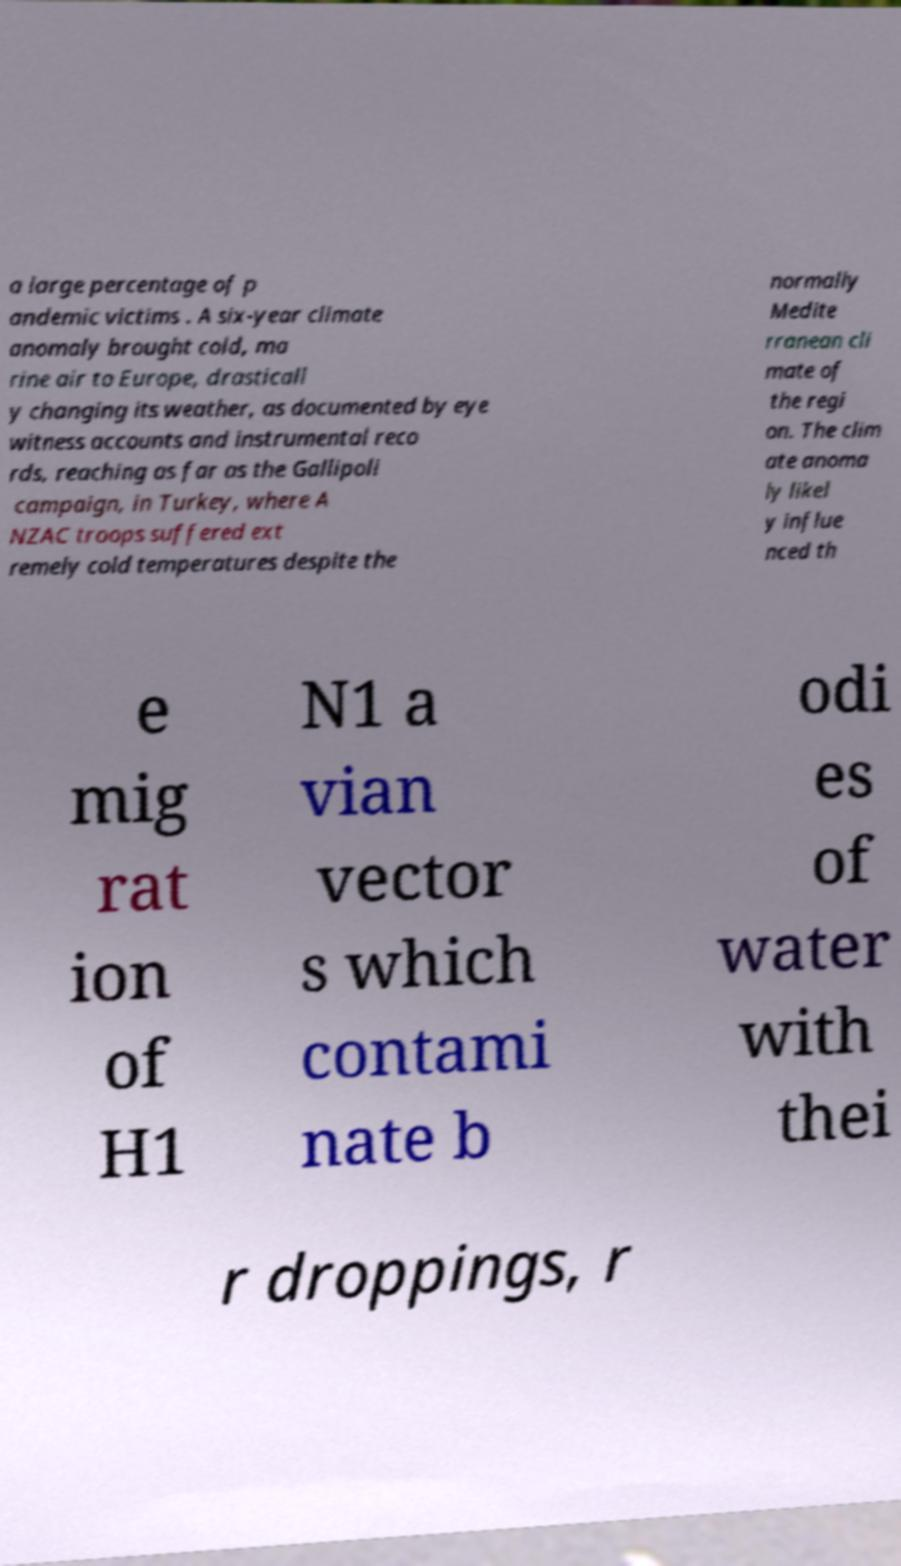There's text embedded in this image that I need extracted. Can you transcribe it verbatim? a large percentage of p andemic victims . A six-year climate anomaly brought cold, ma rine air to Europe, drasticall y changing its weather, as documented by eye witness accounts and instrumental reco rds, reaching as far as the Gallipoli campaign, in Turkey, where A NZAC troops suffered ext remely cold temperatures despite the normally Medite rranean cli mate of the regi on. The clim ate anoma ly likel y influe nced th e mig rat ion of H1 N1 a vian vector s which contami nate b odi es of water with thei r droppings, r 